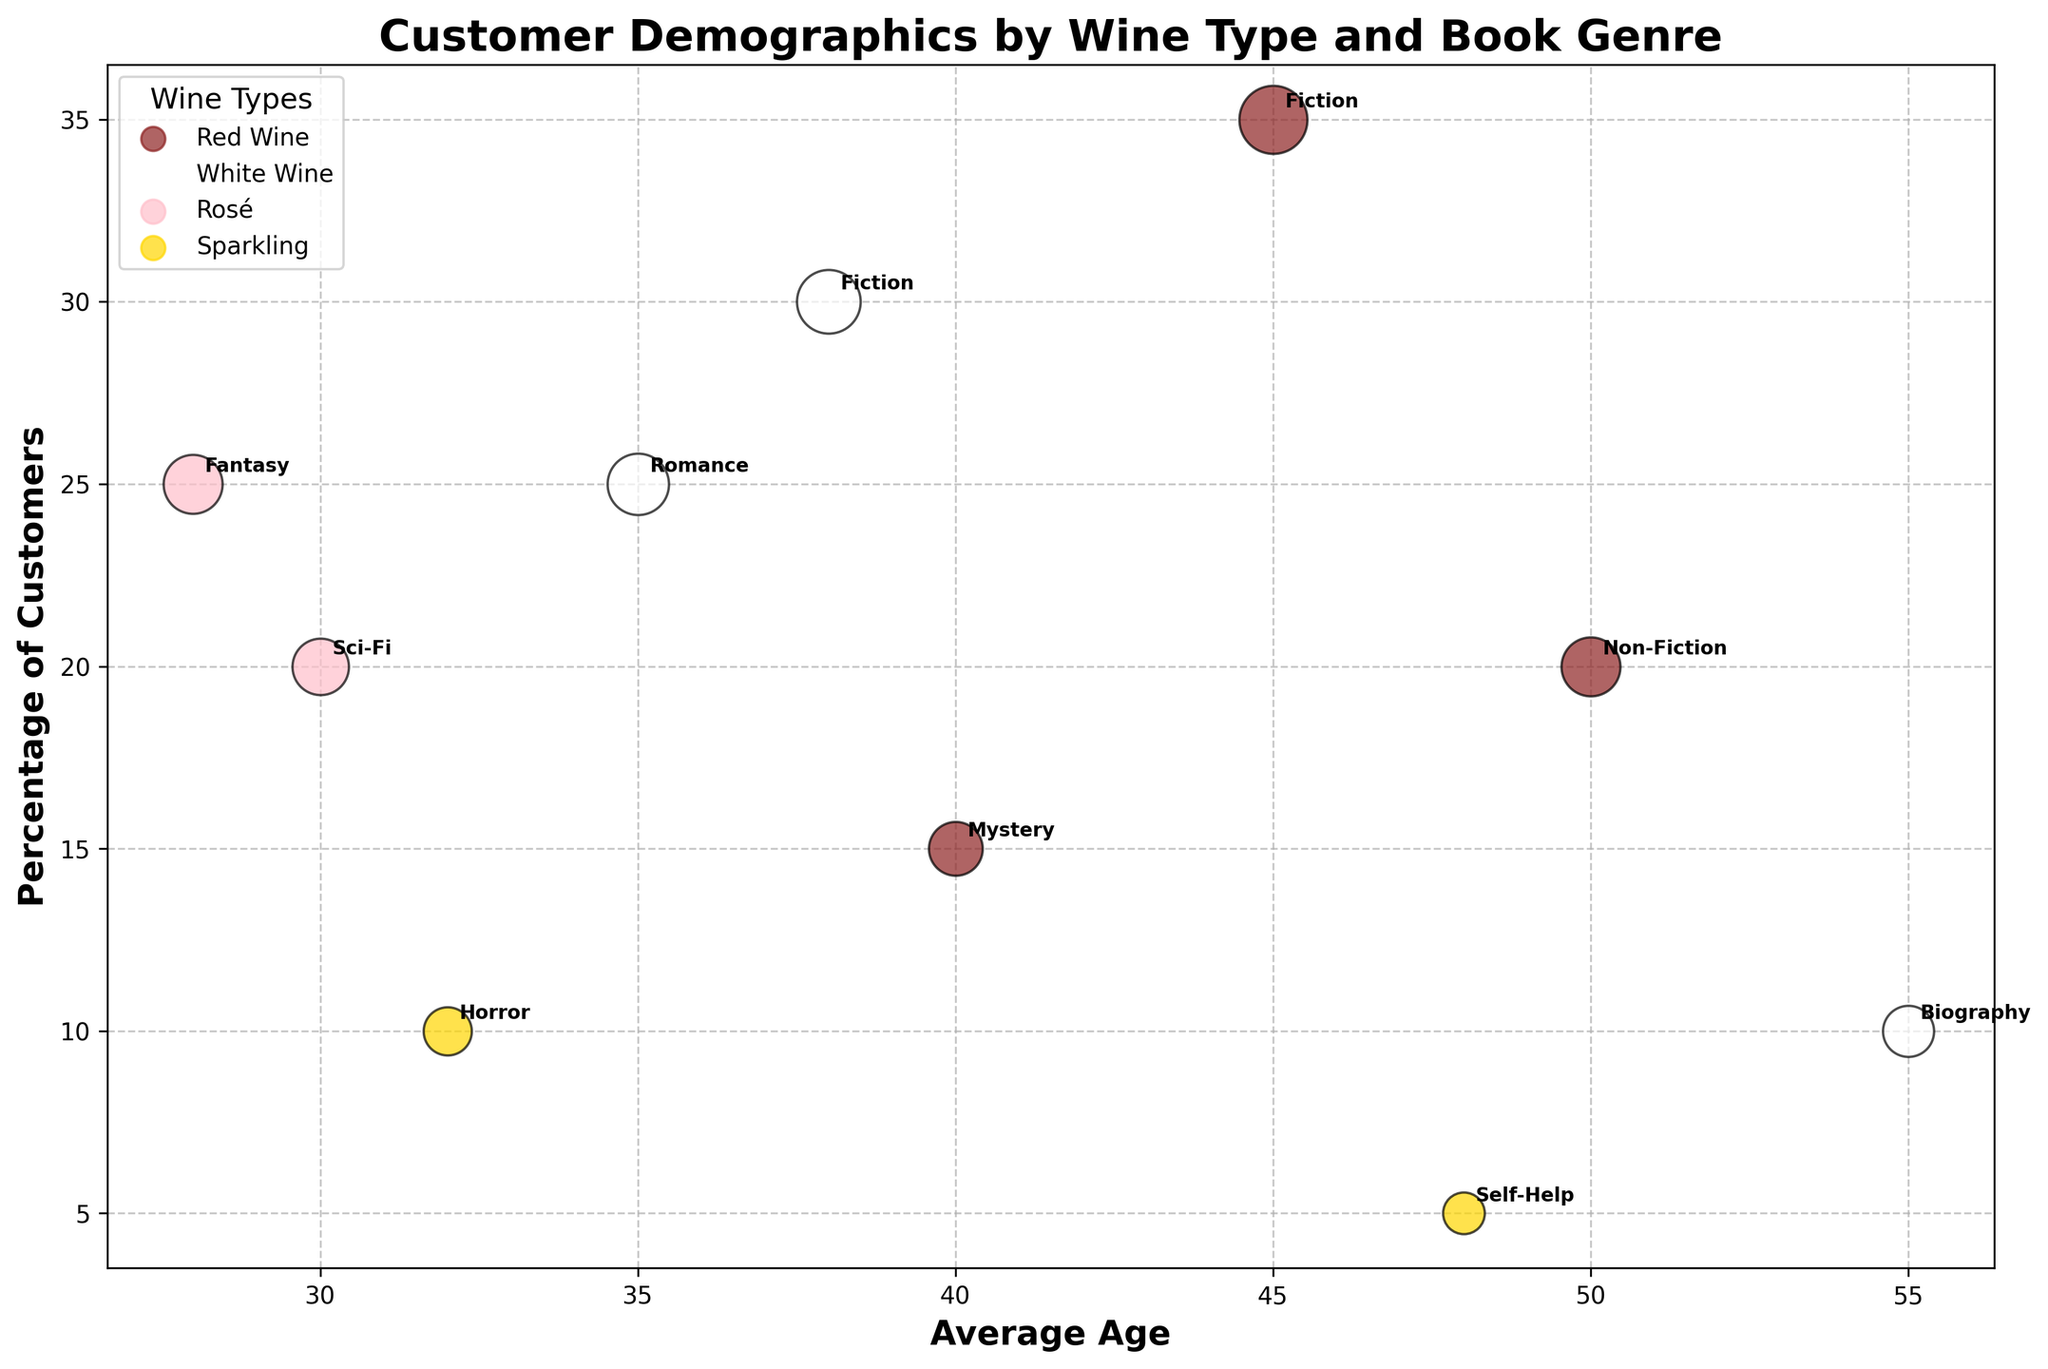How many book genres are associated with Red Wine? To determine the number of book genres associated with Red Wine, we need to count how many unique book genres are mentioned with Red Wine. From the data: Fiction, Non-Fiction, and Mystery are associated with Red Wine, which makes it 3 genres.
Answer: 3 Which wine type has customers with the lowest average age, and what is that average age? For this, we need to identify the wine type with the smallest average age from the plot. Rosé associated with Fantasy has the lowest average age of 28.
Answer: Rosé, 28 What is the average percentage of customers for White Wine book genres? Calculate the average percentage of customers for the book genres associated with White Wine. The data shows Fiction (30%), Romance (25%), and Biography (10%). The average is (30 + 25 + 10) / 3 = 65 / 3 ≈ 21.7%.
Answer: 21.7% Which combination of wine type and book genre displays the largest bubble? Find the combination where the bubble size is the largest. From the data, Red Wine and Fiction has the largest bubble size of 16.
Answer: Red Wine, Fiction Do customers who prefer Sci-Fi also like other types of wine besides Rosé? Check if Sci-Fi is associated with any wine type other than Rosé. According to the data and plot, Sci-Fi is only associated with Rosé.
Answer: No Which book genre has the highest percentage of customers for Sparkling wine? Identify the book genre with the highest percentage of customers for Sparkling wine. The data indicates Horror (10%) and Self-Help (5%). Horror has the highest percentage.
Answer: Horror What is the average age of customers who prefer Rosé wine? Calculate the average age by combining the average ages of Sci-Fi and Fantasy, which are associated with Rosé. The average is (30 + 28) / 2 = 58 / 2 = 29 years.
Answer: 29 years Which book genre has a higher percentage of customers, Fiction with Red Wine or Romance with White Wine? Compare the percentage of customers for Fiction with Red Wine (35%) and Romance with White Wine (25%). Fiction with Red Wine has a higher percentage.
Answer: Fiction with Red Wine Which wine type has the most varied book genres? Count the number of unique book genres associated with each wine type. Red Wine and White Wine both have multiple genres, but the data shows Red Wine is associated with Fiction, Non-Fiction, and Mystery (3 genres), which is the most varied.
Answer: Red Wine What is the difference in the average age of customers between those who prefer Mystery (Red Wine) and those who prefer Biography (White Wine)? Subtract the average age for Mystery (40) from the average age for Biography (55). The difference is 55 - 40 = 15 years.
Answer: 15 years 